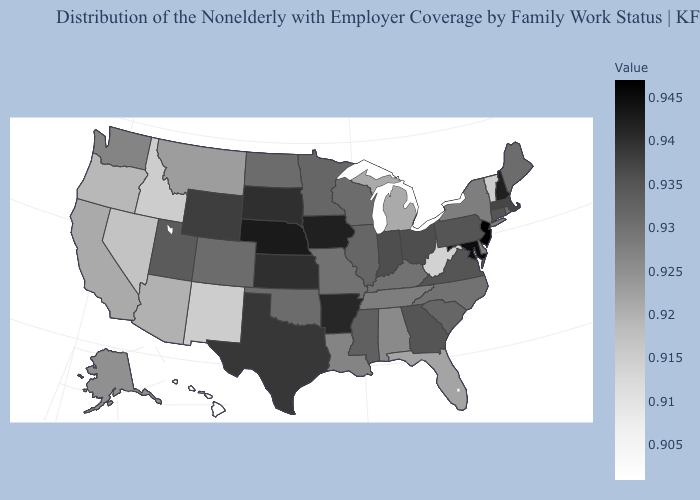Does Georgia have a higher value than New Mexico?
Write a very short answer. Yes. Does the map have missing data?
Write a very short answer. No. Among the states that border New Mexico , which have the highest value?
Write a very short answer. Texas. Does the map have missing data?
Answer briefly. No. Which states hav the highest value in the Northeast?
Keep it brief. New Jersey. Among the states that border Missouri , which have the lowest value?
Be succinct. Tennessee. Which states hav the highest value in the South?
Answer briefly. Maryland. 